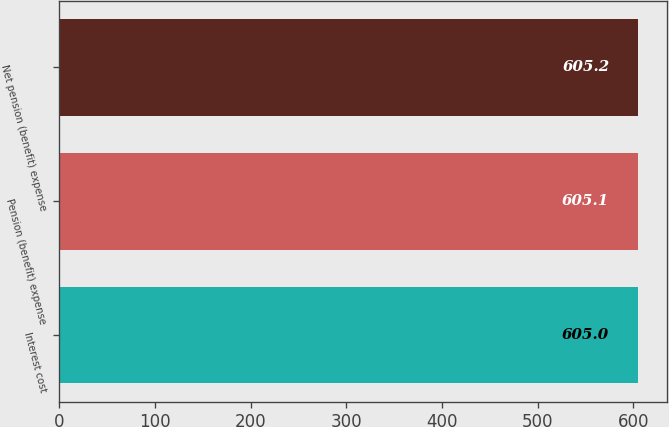<chart> <loc_0><loc_0><loc_500><loc_500><bar_chart><fcel>Interest cost<fcel>Pension (benefit) expense<fcel>Net pension (benefit) expense<nl><fcel>605<fcel>605.1<fcel>605.2<nl></chart> 